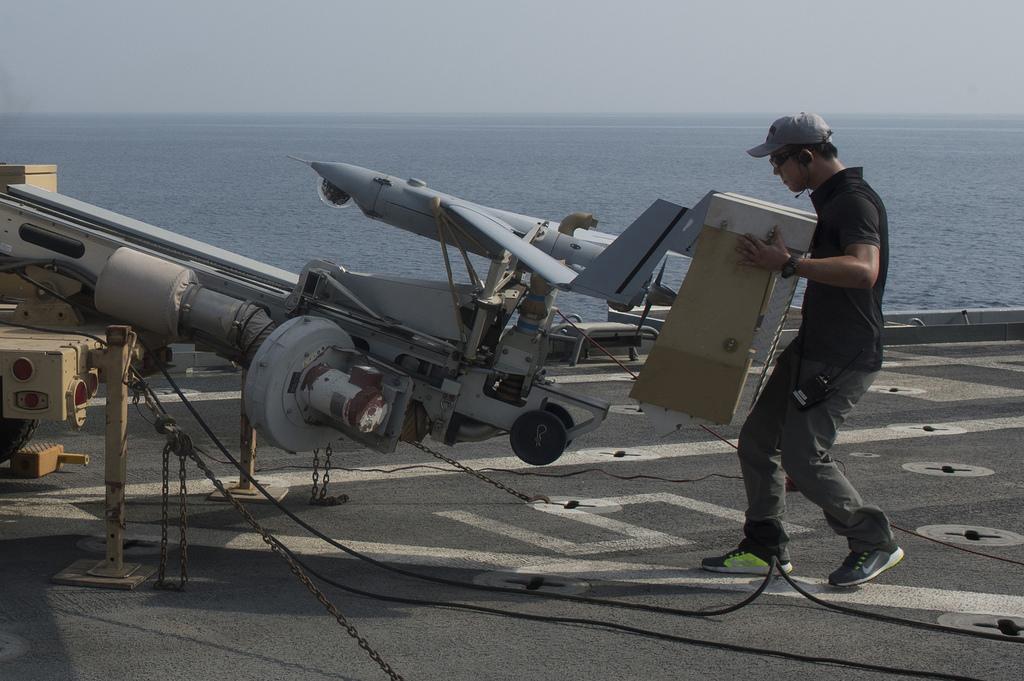In one or two sentences, can you explain what this image depicts? In this image there is a person holding an object is walking towards a missile launcher, beside the missile launcher there is a fighter jet on the ship, beside the ship there is water. 